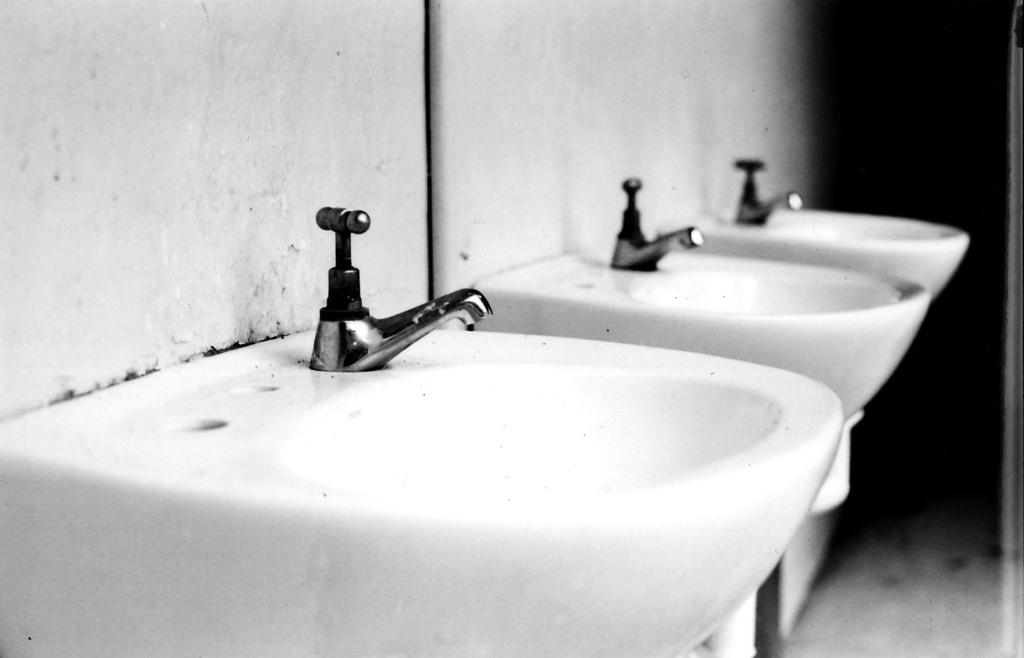What is the color scheme of the image? The image is black and white. What can be seen attached to the wall in the image? There are sinks attached to the wall in the image. What type of government is depicted in the image? There is no depiction of a government in the image; it only features sinks attached to the wall. Can you tell me what kind of doctor is present in the image? There is no doctor present in the image; it only features sinks attached to the wall. 